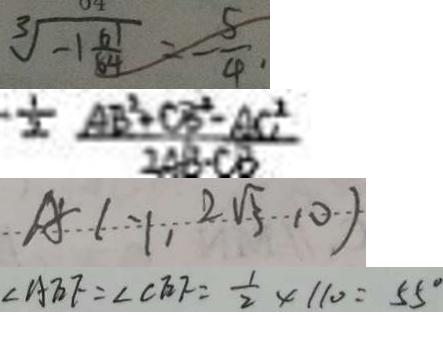<formula> <loc_0><loc_0><loc_500><loc_500>\sqrt [ 3 ] { - 1 \frac { 6 1 } { 8 4 } } = - \frac { 5 } { 4 } \cdot 
 - \frac { 1 } { 2 } \frac { A B ^ { 2 } + C B ^ { 2 } - A C ^ { 2 } } { 2 A B \cdot C B } 
 A = ( - 1 , 2 \sqrt { 5 } , 0 ) 
 \angle A E F = \angle C E F = \frac { 1 } { 2 } \times 1 1 0 = 5 5 ^ { \circ }</formula> 